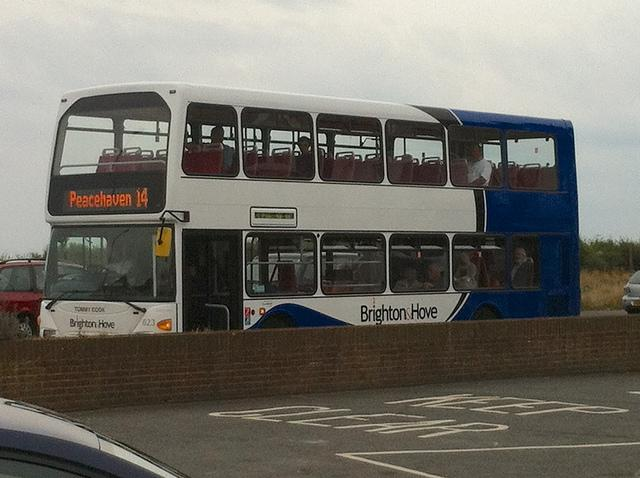In which country's streets does this bus travel?

Choices:
A) briton
B) usa
C) spain
D) portugal briton 